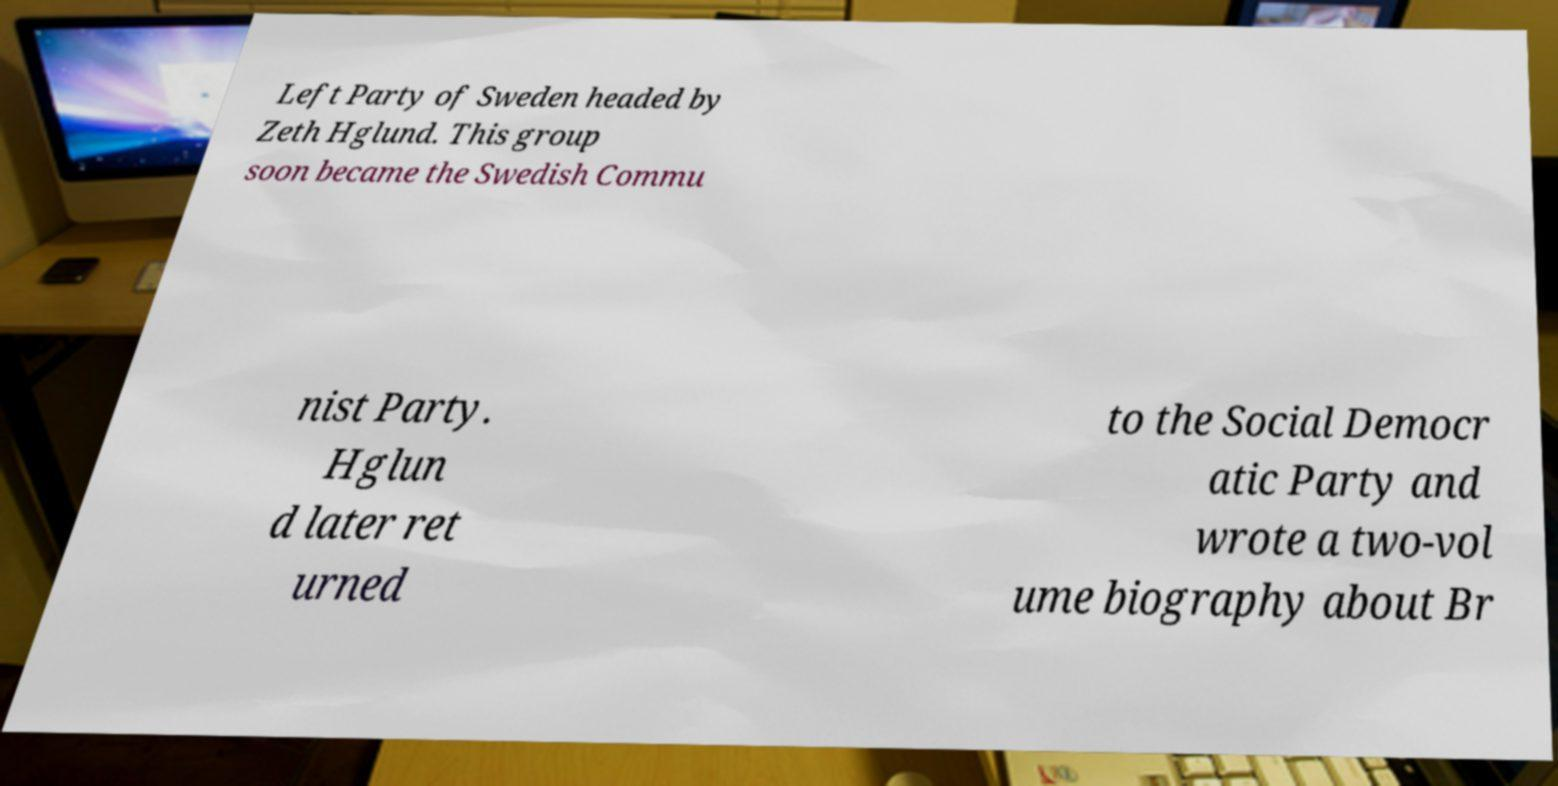I need the written content from this picture converted into text. Can you do that? Left Party of Sweden headed by Zeth Hglund. This group soon became the Swedish Commu nist Party. Hglun d later ret urned to the Social Democr atic Party and wrote a two-vol ume biography about Br 